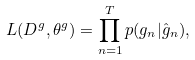<formula> <loc_0><loc_0><loc_500><loc_500>L ( D ^ { g } , \theta ^ { g } ) = \prod _ { n = 1 } ^ { T } p ( g _ { n } | \hat { g } _ { n } ) ,</formula> 